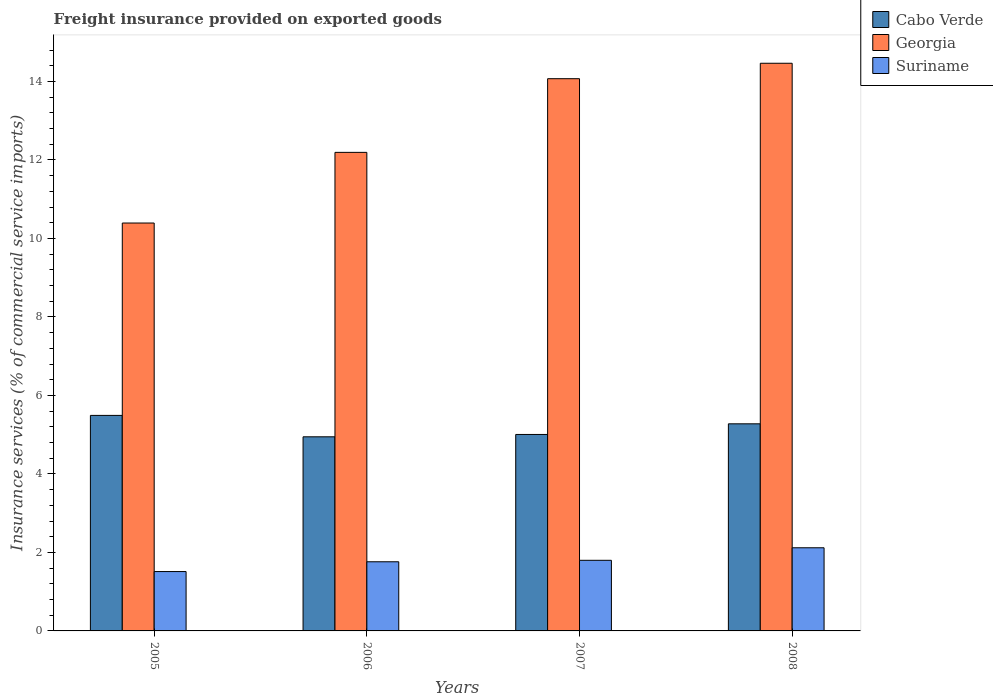How many bars are there on the 1st tick from the right?
Your answer should be very brief. 3. What is the label of the 2nd group of bars from the left?
Provide a short and direct response. 2006. What is the freight insurance provided on exported goods in Cabo Verde in 2007?
Provide a succinct answer. 5.01. Across all years, what is the maximum freight insurance provided on exported goods in Cabo Verde?
Offer a terse response. 5.49. Across all years, what is the minimum freight insurance provided on exported goods in Georgia?
Give a very brief answer. 10.39. In which year was the freight insurance provided on exported goods in Cabo Verde maximum?
Keep it short and to the point. 2005. In which year was the freight insurance provided on exported goods in Georgia minimum?
Provide a succinct answer. 2005. What is the total freight insurance provided on exported goods in Cabo Verde in the graph?
Ensure brevity in your answer.  20.72. What is the difference between the freight insurance provided on exported goods in Georgia in 2007 and that in 2008?
Give a very brief answer. -0.39. What is the difference between the freight insurance provided on exported goods in Suriname in 2007 and the freight insurance provided on exported goods in Cabo Verde in 2006?
Offer a terse response. -3.15. What is the average freight insurance provided on exported goods in Cabo Verde per year?
Offer a terse response. 5.18. In the year 2007, what is the difference between the freight insurance provided on exported goods in Cabo Verde and freight insurance provided on exported goods in Georgia?
Provide a succinct answer. -9.06. In how many years, is the freight insurance provided on exported goods in Cabo Verde greater than 14 %?
Your answer should be compact. 0. What is the ratio of the freight insurance provided on exported goods in Georgia in 2006 to that in 2007?
Offer a very short reply. 0.87. What is the difference between the highest and the second highest freight insurance provided on exported goods in Georgia?
Make the answer very short. 0.39. What is the difference between the highest and the lowest freight insurance provided on exported goods in Georgia?
Your answer should be very brief. 4.07. In how many years, is the freight insurance provided on exported goods in Cabo Verde greater than the average freight insurance provided on exported goods in Cabo Verde taken over all years?
Offer a terse response. 2. Is the sum of the freight insurance provided on exported goods in Cabo Verde in 2006 and 2008 greater than the maximum freight insurance provided on exported goods in Georgia across all years?
Keep it short and to the point. No. What does the 3rd bar from the left in 2005 represents?
Your answer should be compact. Suriname. What does the 2nd bar from the right in 2007 represents?
Give a very brief answer. Georgia. Is it the case that in every year, the sum of the freight insurance provided on exported goods in Georgia and freight insurance provided on exported goods in Suriname is greater than the freight insurance provided on exported goods in Cabo Verde?
Your response must be concise. Yes. How many bars are there?
Offer a terse response. 12. Are all the bars in the graph horizontal?
Give a very brief answer. No. How many years are there in the graph?
Keep it short and to the point. 4. What is the difference between two consecutive major ticks on the Y-axis?
Make the answer very short. 2. Does the graph contain any zero values?
Your response must be concise. No. How many legend labels are there?
Your response must be concise. 3. How are the legend labels stacked?
Your response must be concise. Vertical. What is the title of the graph?
Your answer should be compact. Freight insurance provided on exported goods. What is the label or title of the Y-axis?
Keep it short and to the point. Insurance services (% of commercial service imports). What is the Insurance services (% of commercial service imports) in Cabo Verde in 2005?
Offer a terse response. 5.49. What is the Insurance services (% of commercial service imports) of Georgia in 2005?
Give a very brief answer. 10.39. What is the Insurance services (% of commercial service imports) in Suriname in 2005?
Your response must be concise. 1.51. What is the Insurance services (% of commercial service imports) of Cabo Verde in 2006?
Keep it short and to the point. 4.95. What is the Insurance services (% of commercial service imports) of Georgia in 2006?
Make the answer very short. 12.19. What is the Insurance services (% of commercial service imports) of Suriname in 2006?
Offer a terse response. 1.76. What is the Insurance services (% of commercial service imports) in Cabo Verde in 2007?
Provide a succinct answer. 5.01. What is the Insurance services (% of commercial service imports) in Georgia in 2007?
Keep it short and to the point. 14.07. What is the Insurance services (% of commercial service imports) of Suriname in 2007?
Your answer should be very brief. 1.8. What is the Insurance services (% of commercial service imports) of Cabo Verde in 2008?
Offer a very short reply. 5.28. What is the Insurance services (% of commercial service imports) in Georgia in 2008?
Your answer should be compact. 14.46. What is the Insurance services (% of commercial service imports) in Suriname in 2008?
Offer a very short reply. 2.12. Across all years, what is the maximum Insurance services (% of commercial service imports) of Cabo Verde?
Offer a very short reply. 5.49. Across all years, what is the maximum Insurance services (% of commercial service imports) of Georgia?
Give a very brief answer. 14.46. Across all years, what is the maximum Insurance services (% of commercial service imports) in Suriname?
Your answer should be very brief. 2.12. Across all years, what is the minimum Insurance services (% of commercial service imports) of Cabo Verde?
Offer a terse response. 4.95. Across all years, what is the minimum Insurance services (% of commercial service imports) of Georgia?
Your answer should be very brief. 10.39. Across all years, what is the minimum Insurance services (% of commercial service imports) in Suriname?
Your response must be concise. 1.51. What is the total Insurance services (% of commercial service imports) in Cabo Verde in the graph?
Make the answer very short. 20.72. What is the total Insurance services (% of commercial service imports) of Georgia in the graph?
Your response must be concise. 51.12. What is the total Insurance services (% of commercial service imports) of Suriname in the graph?
Give a very brief answer. 7.19. What is the difference between the Insurance services (% of commercial service imports) of Cabo Verde in 2005 and that in 2006?
Offer a very short reply. 0.55. What is the difference between the Insurance services (% of commercial service imports) in Georgia in 2005 and that in 2006?
Provide a succinct answer. -1.8. What is the difference between the Insurance services (% of commercial service imports) in Suriname in 2005 and that in 2006?
Provide a succinct answer. -0.25. What is the difference between the Insurance services (% of commercial service imports) of Cabo Verde in 2005 and that in 2007?
Make the answer very short. 0.49. What is the difference between the Insurance services (% of commercial service imports) of Georgia in 2005 and that in 2007?
Give a very brief answer. -3.68. What is the difference between the Insurance services (% of commercial service imports) in Suriname in 2005 and that in 2007?
Keep it short and to the point. -0.29. What is the difference between the Insurance services (% of commercial service imports) of Cabo Verde in 2005 and that in 2008?
Make the answer very short. 0.21. What is the difference between the Insurance services (% of commercial service imports) of Georgia in 2005 and that in 2008?
Offer a very short reply. -4.07. What is the difference between the Insurance services (% of commercial service imports) of Suriname in 2005 and that in 2008?
Your response must be concise. -0.61. What is the difference between the Insurance services (% of commercial service imports) of Cabo Verde in 2006 and that in 2007?
Your response must be concise. -0.06. What is the difference between the Insurance services (% of commercial service imports) in Georgia in 2006 and that in 2007?
Your response must be concise. -1.88. What is the difference between the Insurance services (% of commercial service imports) of Suriname in 2006 and that in 2007?
Provide a short and direct response. -0.04. What is the difference between the Insurance services (% of commercial service imports) of Cabo Verde in 2006 and that in 2008?
Ensure brevity in your answer.  -0.33. What is the difference between the Insurance services (% of commercial service imports) of Georgia in 2006 and that in 2008?
Your answer should be compact. -2.27. What is the difference between the Insurance services (% of commercial service imports) of Suriname in 2006 and that in 2008?
Make the answer very short. -0.36. What is the difference between the Insurance services (% of commercial service imports) of Cabo Verde in 2007 and that in 2008?
Your answer should be very brief. -0.27. What is the difference between the Insurance services (% of commercial service imports) in Georgia in 2007 and that in 2008?
Offer a terse response. -0.39. What is the difference between the Insurance services (% of commercial service imports) in Suriname in 2007 and that in 2008?
Make the answer very short. -0.32. What is the difference between the Insurance services (% of commercial service imports) of Cabo Verde in 2005 and the Insurance services (% of commercial service imports) of Georgia in 2006?
Your response must be concise. -6.7. What is the difference between the Insurance services (% of commercial service imports) in Cabo Verde in 2005 and the Insurance services (% of commercial service imports) in Suriname in 2006?
Give a very brief answer. 3.73. What is the difference between the Insurance services (% of commercial service imports) of Georgia in 2005 and the Insurance services (% of commercial service imports) of Suriname in 2006?
Your answer should be very brief. 8.63. What is the difference between the Insurance services (% of commercial service imports) of Cabo Verde in 2005 and the Insurance services (% of commercial service imports) of Georgia in 2007?
Your response must be concise. -8.58. What is the difference between the Insurance services (% of commercial service imports) in Cabo Verde in 2005 and the Insurance services (% of commercial service imports) in Suriname in 2007?
Give a very brief answer. 3.69. What is the difference between the Insurance services (% of commercial service imports) in Georgia in 2005 and the Insurance services (% of commercial service imports) in Suriname in 2007?
Offer a terse response. 8.59. What is the difference between the Insurance services (% of commercial service imports) of Cabo Verde in 2005 and the Insurance services (% of commercial service imports) of Georgia in 2008?
Give a very brief answer. -8.97. What is the difference between the Insurance services (% of commercial service imports) in Cabo Verde in 2005 and the Insurance services (% of commercial service imports) in Suriname in 2008?
Give a very brief answer. 3.37. What is the difference between the Insurance services (% of commercial service imports) in Georgia in 2005 and the Insurance services (% of commercial service imports) in Suriname in 2008?
Your answer should be very brief. 8.27. What is the difference between the Insurance services (% of commercial service imports) of Cabo Verde in 2006 and the Insurance services (% of commercial service imports) of Georgia in 2007?
Your answer should be compact. -9.12. What is the difference between the Insurance services (% of commercial service imports) in Cabo Verde in 2006 and the Insurance services (% of commercial service imports) in Suriname in 2007?
Your response must be concise. 3.15. What is the difference between the Insurance services (% of commercial service imports) in Georgia in 2006 and the Insurance services (% of commercial service imports) in Suriname in 2007?
Your response must be concise. 10.39. What is the difference between the Insurance services (% of commercial service imports) in Cabo Verde in 2006 and the Insurance services (% of commercial service imports) in Georgia in 2008?
Provide a short and direct response. -9.52. What is the difference between the Insurance services (% of commercial service imports) of Cabo Verde in 2006 and the Insurance services (% of commercial service imports) of Suriname in 2008?
Your answer should be compact. 2.83. What is the difference between the Insurance services (% of commercial service imports) of Georgia in 2006 and the Insurance services (% of commercial service imports) of Suriname in 2008?
Make the answer very short. 10.07. What is the difference between the Insurance services (% of commercial service imports) in Cabo Verde in 2007 and the Insurance services (% of commercial service imports) in Georgia in 2008?
Provide a short and direct response. -9.46. What is the difference between the Insurance services (% of commercial service imports) in Cabo Verde in 2007 and the Insurance services (% of commercial service imports) in Suriname in 2008?
Make the answer very short. 2.89. What is the difference between the Insurance services (% of commercial service imports) of Georgia in 2007 and the Insurance services (% of commercial service imports) of Suriname in 2008?
Ensure brevity in your answer.  11.95. What is the average Insurance services (% of commercial service imports) in Cabo Verde per year?
Provide a succinct answer. 5.18. What is the average Insurance services (% of commercial service imports) in Georgia per year?
Provide a short and direct response. 12.78. What is the average Insurance services (% of commercial service imports) in Suriname per year?
Your answer should be compact. 1.8. In the year 2005, what is the difference between the Insurance services (% of commercial service imports) in Cabo Verde and Insurance services (% of commercial service imports) in Georgia?
Your answer should be compact. -4.9. In the year 2005, what is the difference between the Insurance services (% of commercial service imports) of Cabo Verde and Insurance services (% of commercial service imports) of Suriname?
Offer a terse response. 3.98. In the year 2005, what is the difference between the Insurance services (% of commercial service imports) in Georgia and Insurance services (% of commercial service imports) in Suriname?
Provide a succinct answer. 8.88. In the year 2006, what is the difference between the Insurance services (% of commercial service imports) in Cabo Verde and Insurance services (% of commercial service imports) in Georgia?
Give a very brief answer. -7.25. In the year 2006, what is the difference between the Insurance services (% of commercial service imports) in Cabo Verde and Insurance services (% of commercial service imports) in Suriname?
Give a very brief answer. 3.18. In the year 2006, what is the difference between the Insurance services (% of commercial service imports) of Georgia and Insurance services (% of commercial service imports) of Suriname?
Make the answer very short. 10.43. In the year 2007, what is the difference between the Insurance services (% of commercial service imports) of Cabo Verde and Insurance services (% of commercial service imports) of Georgia?
Offer a terse response. -9.06. In the year 2007, what is the difference between the Insurance services (% of commercial service imports) of Cabo Verde and Insurance services (% of commercial service imports) of Suriname?
Give a very brief answer. 3.21. In the year 2007, what is the difference between the Insurance services (% of commercial service imports) of Georgia and Insurance services (% of commercial service imports) of Suriname?
Provide a succinct answer. 12.27. In the year 2008, what is the difference between the Insurance services (% of commercial service imports) in Cabo Verde and Insurance services (% of commercial service imports) in Georgia?
Keep it short and to the point. -9.19. In the year 2008, what is the difference between the Insurance services (% of commercial service imports) of Cabo Verde and Insurance services (% of commercial service imports) of Suriname?
Your response must be concise. 3.16. In the year 2008, what is the difference between the Insurance services (% of commercial service imports) in Georgia and Insurance services (% of commercial service imports) in Suriname?
Offer a terse response. 12.34. What is the ratio of the Insurance services (% of commercial service imports) of Cabo Verde in 2005 to that in 2006?
Provide a short and direct response. 1.11. What is the ratio of the Insurance services (% of commercial service imports) of Georgia in 2005 to that in 2006?
Ensure brevity in your answer.  0.85. What is the ratio of the Insurance services (% of commercial service imports) in Suriname in 2005 to that in 2006?
Keep it short and to the point. 0.86. What is the ratio of the Insurance services (% of commercial service imports) of Cabo Verde in 2005 to that in 2007?
Your answer should be very brief. 1.1. What is the ratio of the Insurance services (% of commercial service imports) of Georgia in 2005 to that in 2007?
Your response must be concise. 0.74. What is the ratio of the Insurance services (% of commercial service imports) of Suriname in 2005 to that in 2007?
Your response must be concise. 0.84. What is the ratio of the Insurance services (% of commercial service imports) of Cabo Verde in 2005 to that in 2008?
Ensure brevity in your answer.  1.04. What is the ratio of the Insurance services (% of commercial service imports) in Georgia in 2005 to that in 2008?
Offer a very short reply. 0.72. What is the ratio of the Insurance services (% of commercial service imports) of Suriname in 2005 to that in 2008?
Offer a terse response. 0.71. What is the ratio of the Insurance services (% of commercial service imports) of Cabo Verde in 2006 to that in 2007?
Ensure brevity in your answer.  0.99. What is the ratio of the Insurance services (% of commercial service imports) in Georgia in 2006 to that in 2007?
Keep it short and to the point. 0.87. What is the ratio of the Insurance services (% of commercial service imports) of Suriname in 2006 to that in 2007?
Your answer should be very brief. 0.98. What is the ratio of the Insurance services (% of commercial service imports) of Cabo Verde in 2006 to that in 2008?
Make the answer very short. 0.94. What is the ratio of the Insurance services (% of commercial service imports) in Georgia in 2006 to that in 2008?
Provide a succinct answer. 0.84. What is the ratio of the Insurance services (% of commercial service imports) in Suriname in 2006 to that in 2008?
Keep it short and to the point. 0.83. What is the ratio of the Insurance services (% of commercial service imports) in Cabo Verde in 2007 to that in 2008?
Your answer should be compact. 0.95. What is the ratio of the Insurance services (% of commercial service imports) in Georgia in 2007 to that in 2008?
Provide a succinct answer. 0.97. What is the ratio of the Insurance services (% of commercial service imports) of Suriname in 2007 to that in 2008?
Give a very brief answer. 0.85. What is the difference between the highest and the second highest Insurance services (% of commercial service imports) in Cabo Verde?
Offer a terse response. 0.21. What is the difference between the highest and the second highest Insurance services (% of commercial service imports) of Georgia?
Keep it short and to the point. 0.39. What is the difference between the highest and the second highest Insurance services (% of commercial service imports) in Suriname?
Keep it short and to the point. 0.32. What is the difference between the highest and the lowest Insurance services (% of commercial service imports) of Cabo Verde?
Offer a terse response. 0.55. What is the difference between the highest and the lowest Insurance services (% of commercial service imports) of Georgia?
Provide a succinct answer. 4.07. What is the difference between the highest and the lowest Insurance services (% of commercial service imports) in Suriname?
Your answer should be compact. 0.61. 